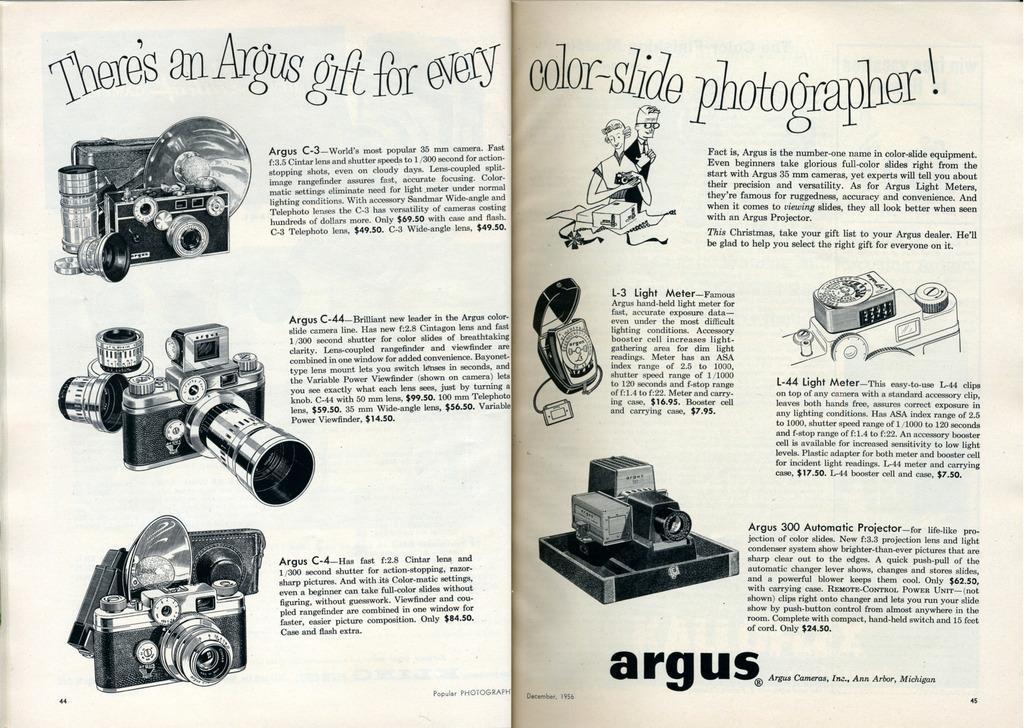Please provide a concise description of this image. This picture is taken from the textbook. In this picture, we see text written on the papers. On the left side, we see the pictures of cameras and camcorders. 